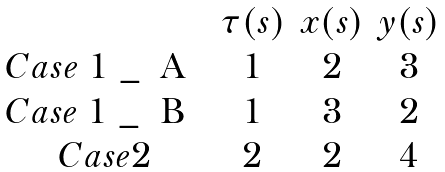<formula> <loc_0><loc_0><loc_500><loc_500>\begin{matrix} & \tau ( s ) & x ( s ) & y ( s ) \\ C a s e $ 1 _ { A } $ & 1 & 2 & 3 \\ C a s e $ 1 _ { B } $ & 1 & 3 & 2 \\ C a s e 2 & 2 & 2 & 4 \\ \end{matrix}</formula> 